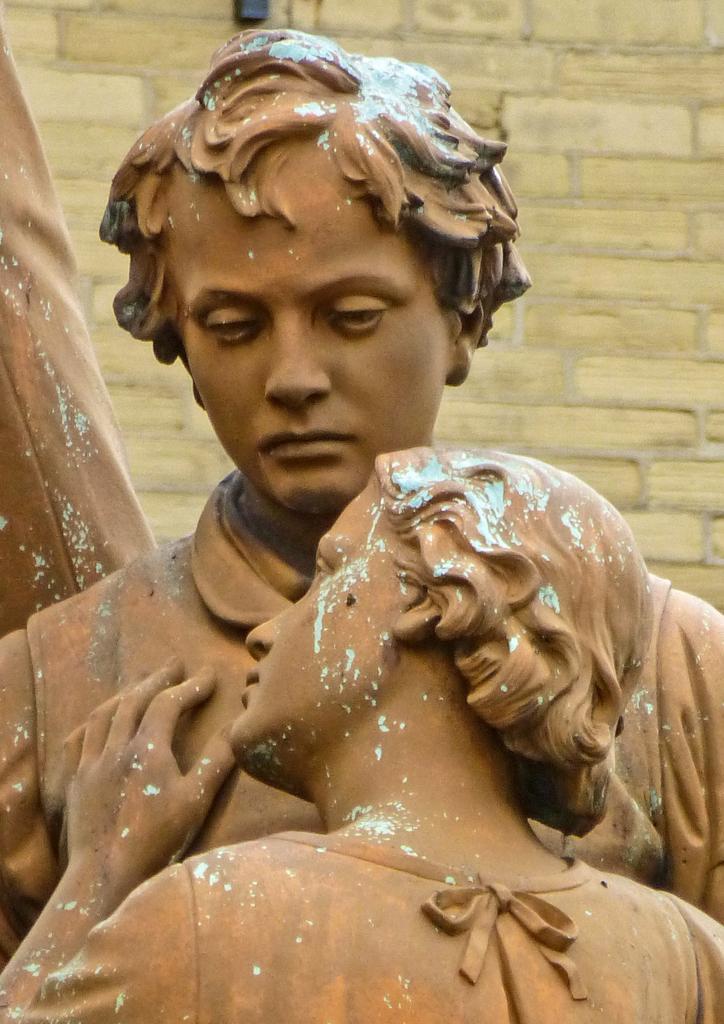Describe this image in one or two sentences. In this image there is a statue. In the background there is a wall. 